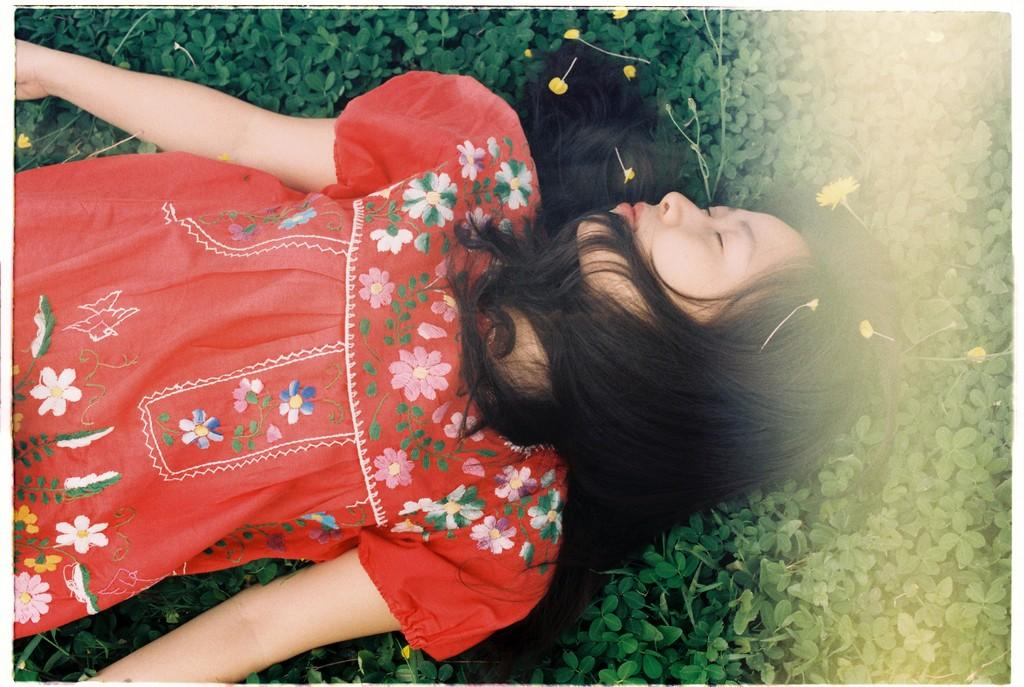What is the main subject of the image? The main subject of the image is a woman. What is the woman doing in the image? The woman is laying on plants. What is the woman wearing in the image? The woman is wearing a red dress. What type of operation is the woman undergoing in the image? There is no indication in the image that the woman is undergoing any operation. What type of teeth can be seen in the image? There are no teeth visible in the image, as it features a woman laying on plants while wearing a red dress. 